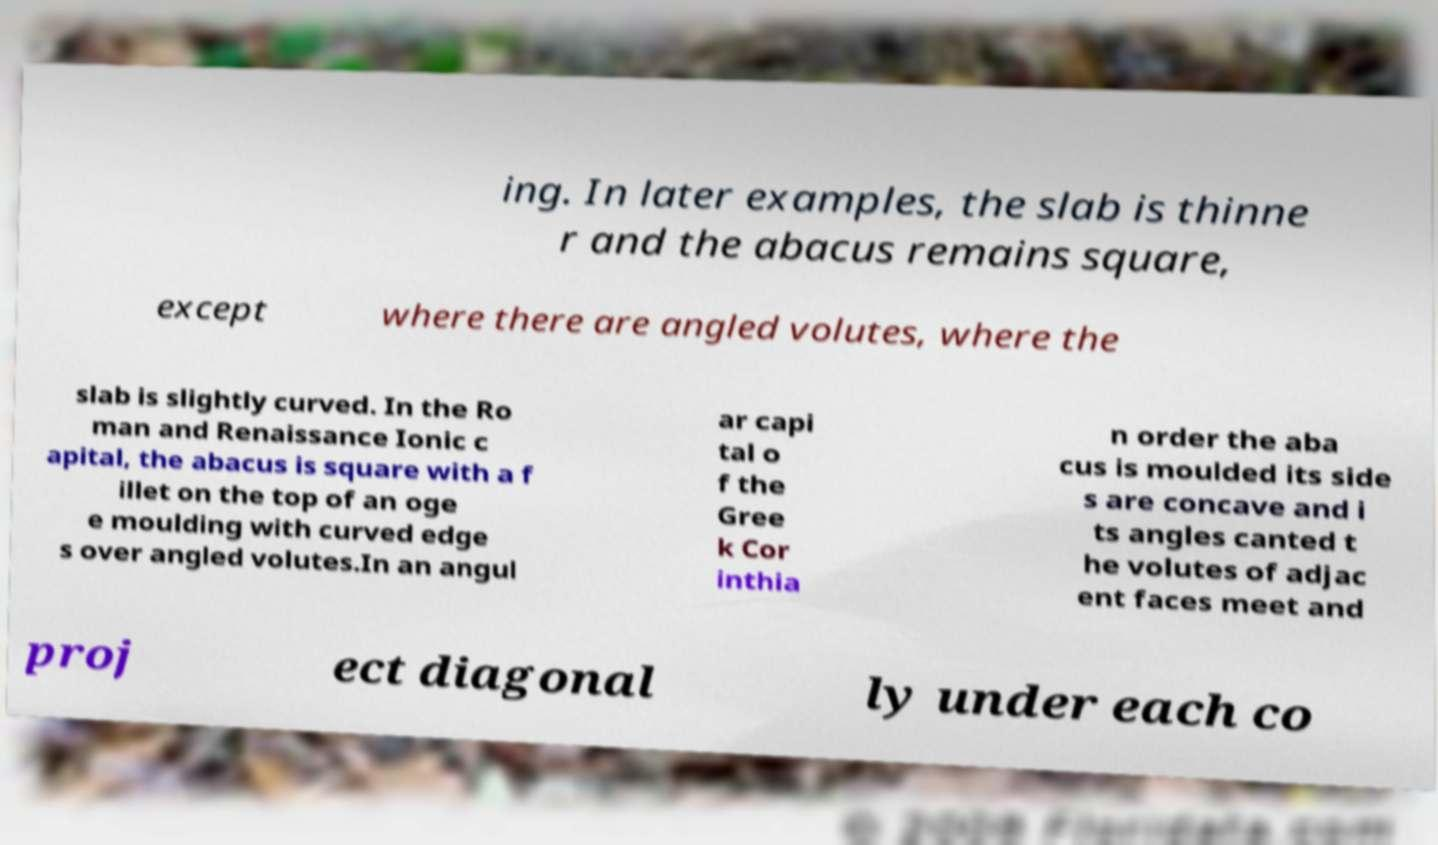I need the written content from this picture converted into text. Can you do that? ing. In later examples, the slab is thinne r and the abacus remains square, except where there are angled volutes, where the slab is slightly curved. In the Ro man and Renaissance Ionic c apital, the abacus is square with a f illet on the top of an oge e moulding with curved edge s over angled volutes.In an angul ar capi tal o f the Gree k Cor inthia n order the aba cus is moulded its side s are concave and i ts angles canted t he volutes of adjac ent faces meet and proj ect diagonal ly under each co 